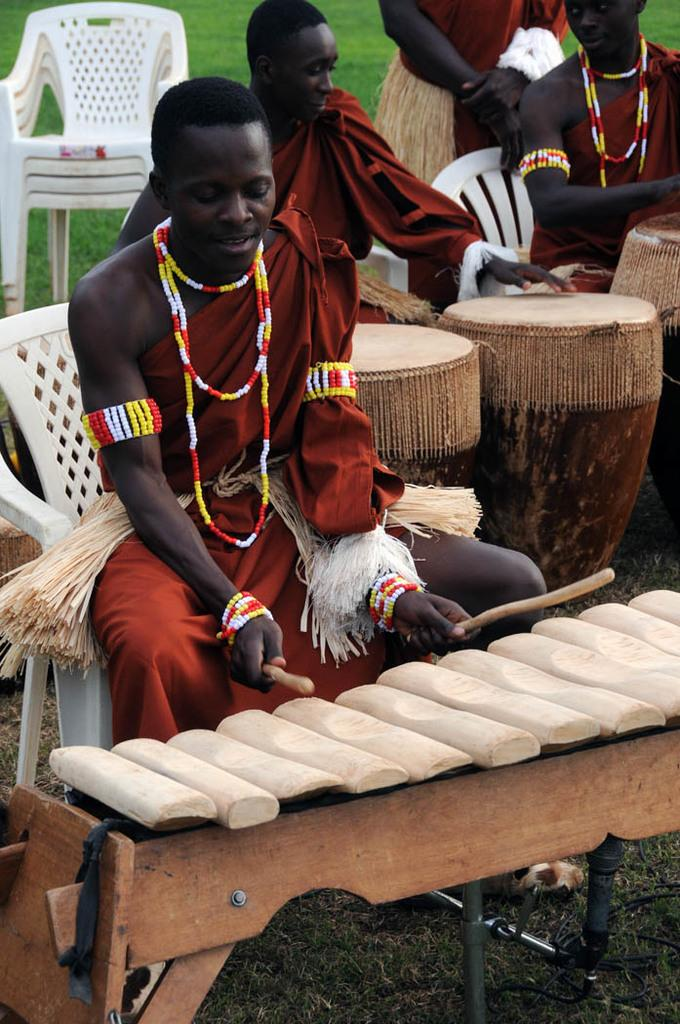How many people are in the image? There are four persons in the image. What are the persons doing in the image? The persons are preparing food items. What are the persons sitting on while preparing food? The persons are sitting on chairs. What color is the cloth worn by the persons? The persons are wearing red cloth. What type of accessory is worn by the persons? The persons are wearing stone necklaces. What type of cable is being used by the persons to shock each other in the image? There is no cable or shocking activity present in the image; the persons are simply preparing food items while sitting on chairs. 